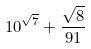<formula> <loc_0><loc_0><loc_500><loc_500>1 0 ^ { \sqrt { 7 } } + \frac { \sqrt { 8 } } { 9 1 }</formula> 